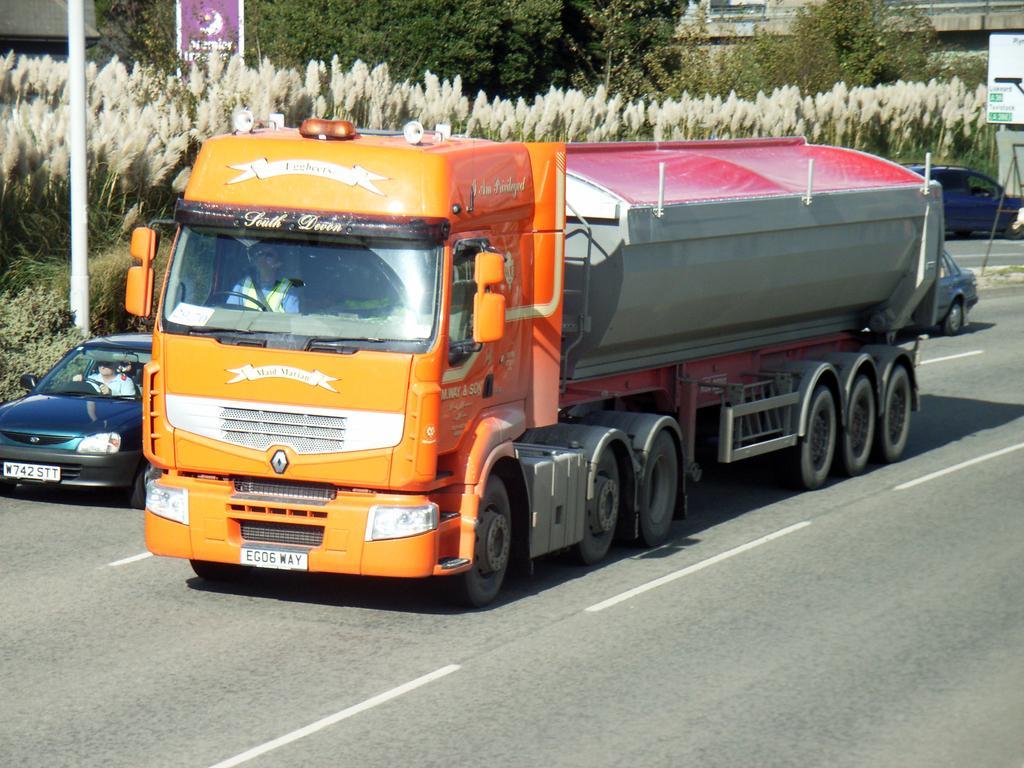How would you summarize this image in a sentence or two? There are 2 persons riding a car and vehicle on the road respectively. Behind them there are trees. 